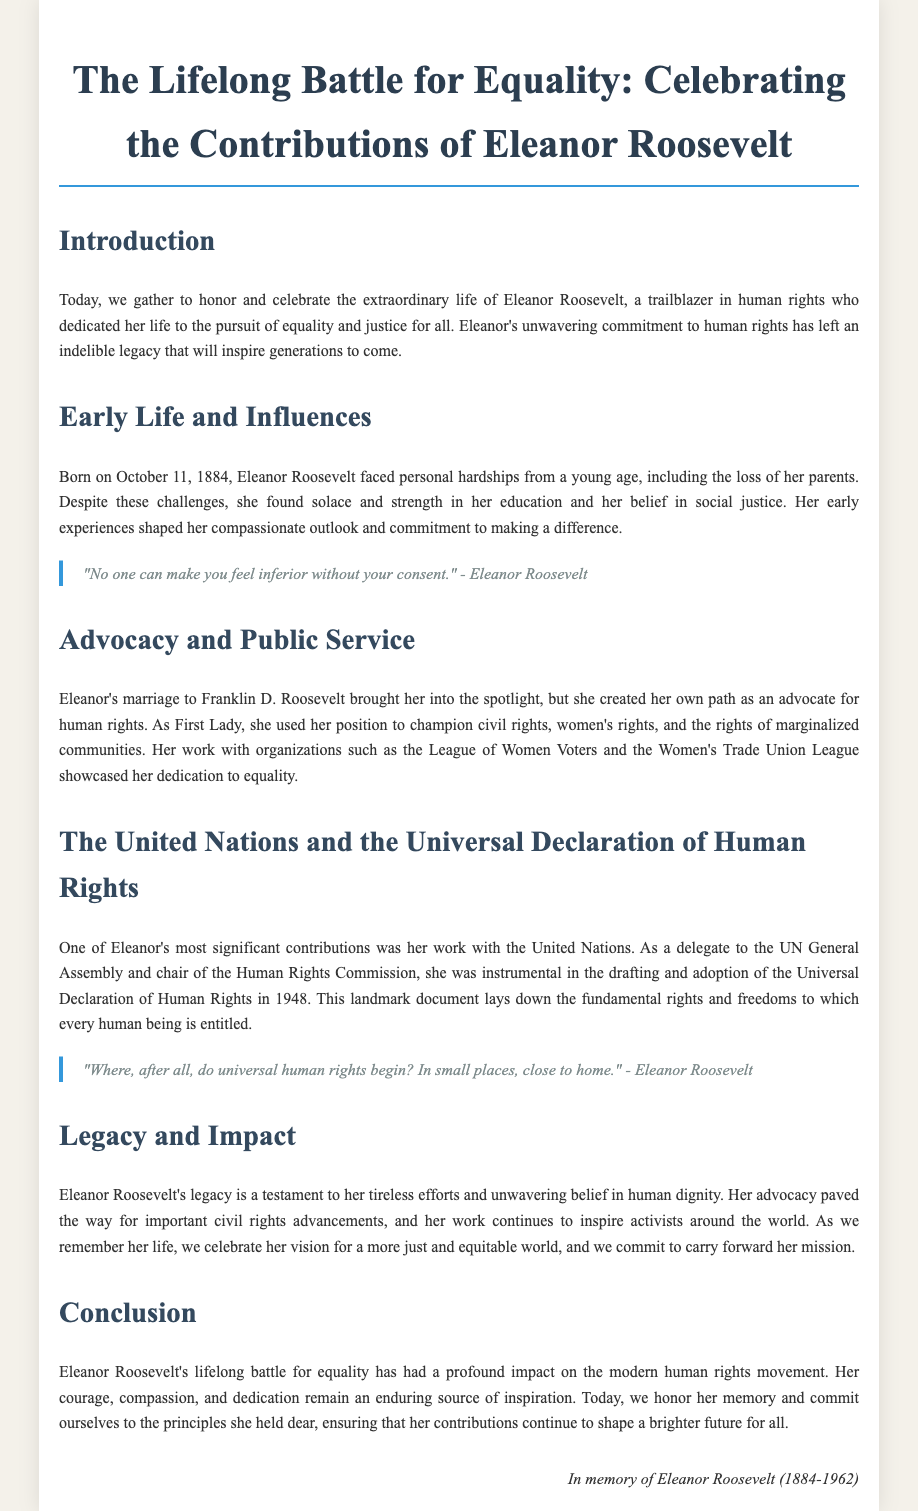What is the title of the document? The title reflects the main subject and purpose of the eulogy, which is the life and contributions of Eleanor Roosevelt.
Answer: The Lifelong Battle for Equality: Celebrating the Contributions of Eleanor Roosevelt When was Eleanor Roosevelt born? The document provides the birth date of Eleanor Roosevelt, which is mentioned in the section on her early life.
Answer: October 11, 1884 What significant document did Eleanor Roosevelt help draft? The eulogy highlights Eleanor's involvement with the United Nations and a specific important document related to human rights.
Answer: Universal Declaration of Human Rights What position did Eleanor Roosevelt hold during her marriage? This detail pertains to her societal role, which is key to understanding her influence and advocacy.
Answer: First Lady Which quote reflects Eleanor Roosevelt's view on human rights? The document includes direct quotes from Eleanor that encapsulate her beliefs regarding human rights.
Answer: "Where, after all, do universal human rights begin? In small places, close to home." What was one impact of Eleanor Roosevelt's advocacy? The eulogy summarizes the implications of Eleanor's work, which aligns with broader social movements.
Answer: Civil rights advancements What year did Eleanor Roosevelt pass away? The closing of the document includes her date of death, relevant to her legacy.
Answer: 1962 